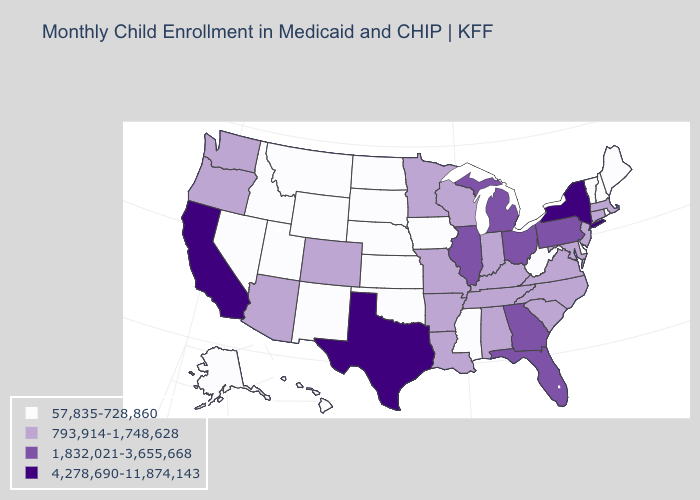Name the states that have a value in the range 57,835-728,860?
Answer briefly. Alaska, Delaware, Hawaii, Idaho, Iowa, Kansas, Maine, Mississippi, Montana, Nebraska, Nevada, New Hampshire, New Mexico, North Dakota, Oklahoma, Rhode Island, South Dakota, Utah, Vermont, West Virginia, Wyoming. Which states have the highest value in the USA?
Be succinct. California, New York, Texas. Name the states that have a value in the range 1,832,021-3,655,668?
Quick response, please. Florida, Georgia, Illinois, Michigan, Ohio, Pennsylvania. Which states hav the highest value in the West?
Quick response, please. California. What is the value of Louisiana?
Give a very brief answer. 793,914-1,748,628. What is the value of Oregon?
Concise answer only. 793,914-1,748,628. Does Hawaii have the same value as South Dakota?
Be succinct. Yes. Name the states that have a value in the range 1,832,021-3,655,668?
Concise answer only. Florida, Georgia, Illinois, Michigan, Ohio, Pennsylvania. Name the states that have a value in the range 4,278,690-11,874,143?
Be succinct. California, New York, Texas. What is the value of Mississippi?
Be succinct. 57,835-728,860. Which states have the lowest value in the South?
Quick response, please. Delaware, Mississippi, Oklahoma, West Virginia. Does New York have the highest value in the Northeast?
Give a very brief answer. Yes. Does Maine have the same value as North Dakota?
Quick response, please. Yes. Does Virginia have a higher value than Kansas?
Keep it brief. Yes. What is the value of Virginia?
Quick response, please. 793,914-1,748,628. 